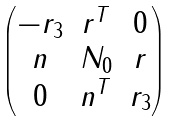Convert formula to latex. <formula><loc_0><loc_0><loc_500><loc_500>\begin{pmatrix} - r _ { 3 } & r ^ { T } & 0 \\ n & N _ { 0 } & r \\ 0 & n ^ { T } & r _ { 3 } \end{pmatrix}</formula> 